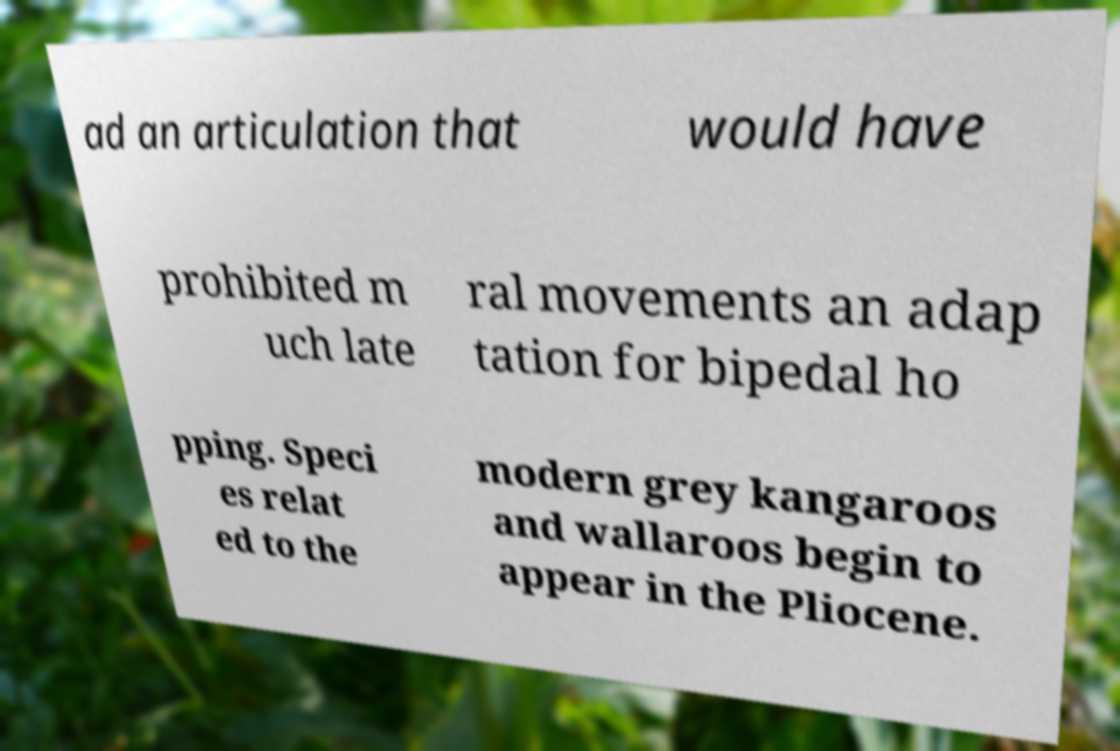For documentation purposes, I need the text within this image transcribed. Could you provide that? ad an articulation that would have prohibited m uch late ral movements an adap tation for bipedal ho pping. Speci es relat ed to the modern grey kangaroos and wallaroos begin to appear in the Pliocene. 